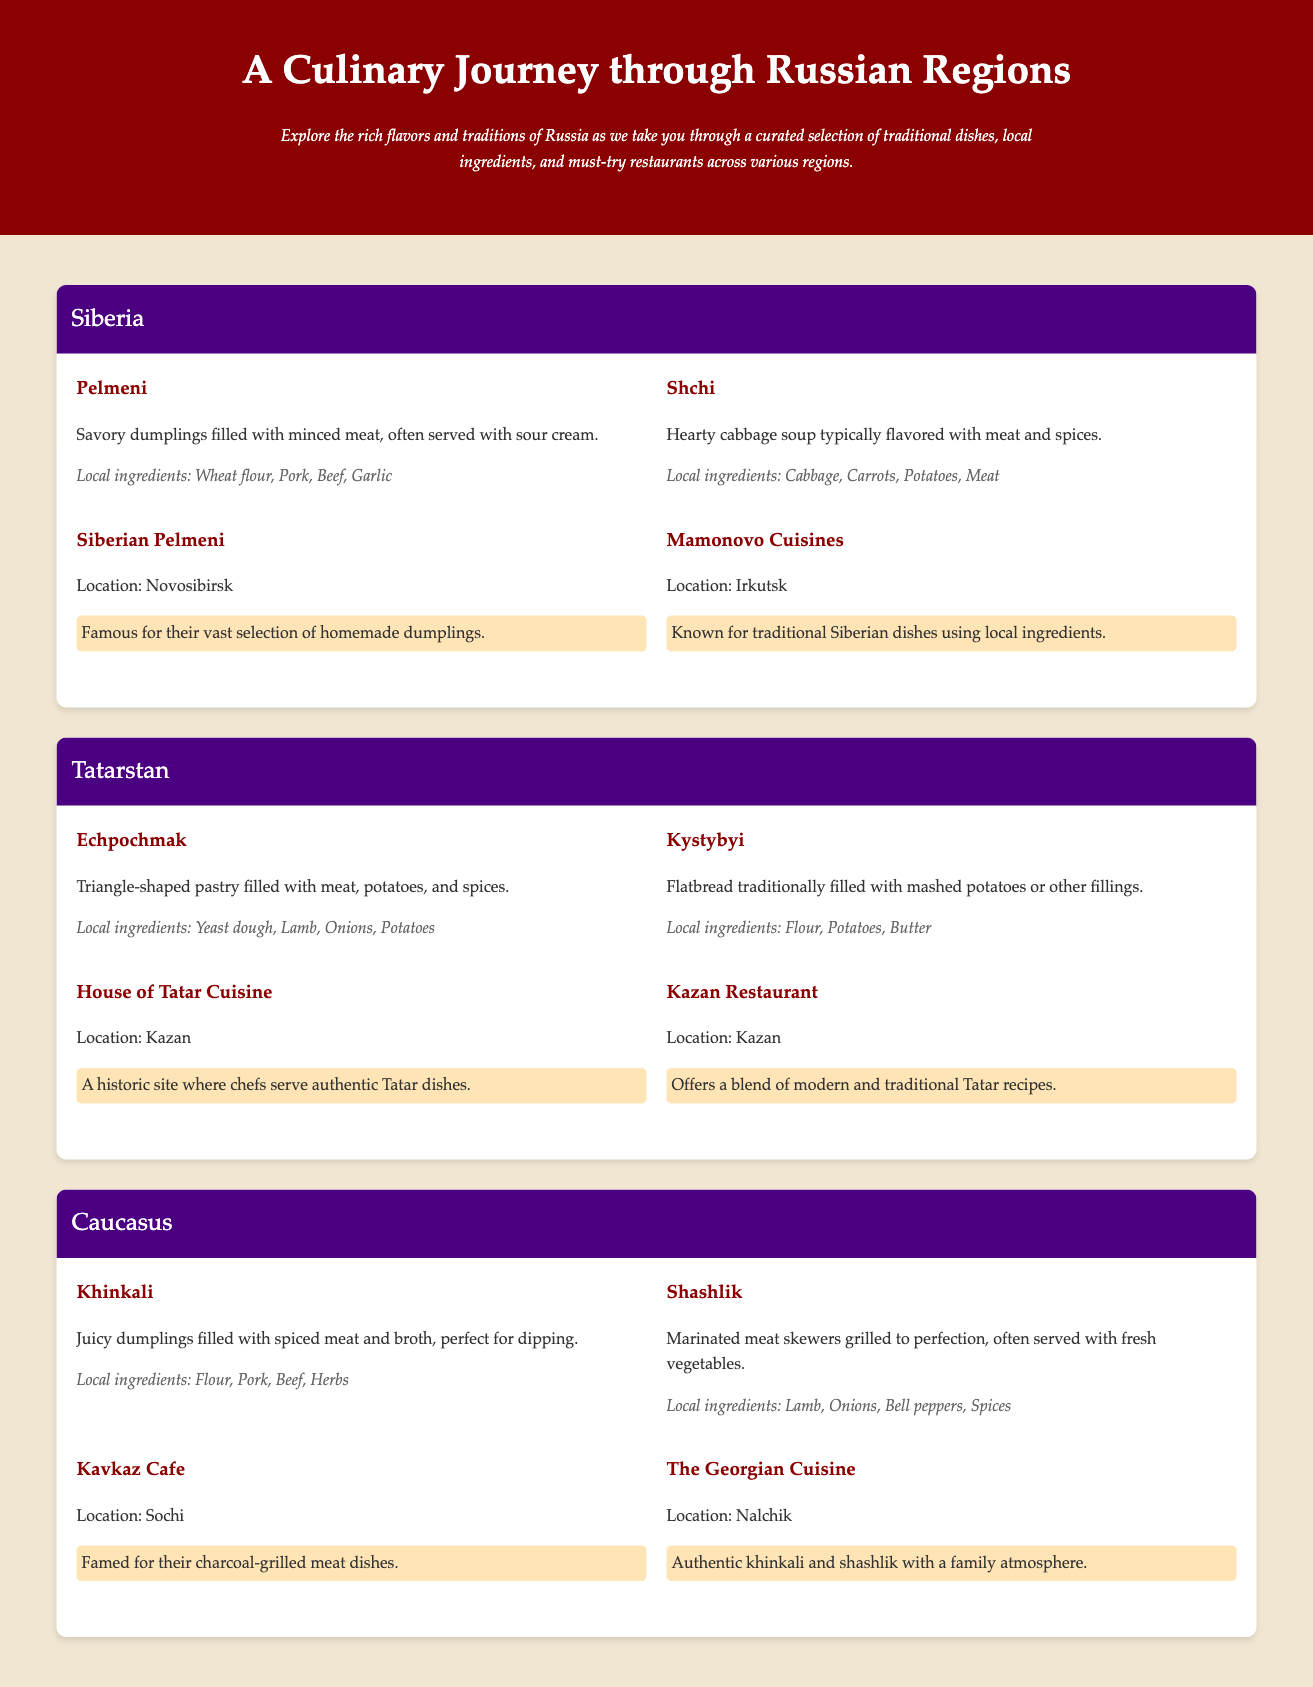What is the first dish listed under Siberia? The first dish under Siberia in the document is Pelmeni, which is mentioned first in the section for that region.
Answer: Pelmeni How many restaurants are listed for Tatarstan? The document lists two restaurants in the Tatarstan section, which are House of Tatar Cuisine and Kazan Restaurant.
Answer: 2 What local ingredient is used in both Khinkali and Shashlik? The local ingredient common to both Khinkali and Shashlik is meat, as both dishes feature spiced meat in their descriptions.
Answer: Meat Which region's restaurant is called Siberian Pelmeni? The restaurant called Siberian Pelmeni is located in the Siberia region, as indicated in the document’s restaurant listing for that area.
Answer: Siberia What type of cuisine is served at Kavkaz Cafe? Kavkaz Cafe serves charcoal-grilled meat dishes, as mentioned in the description of the restaurant in the Caucasus section.
Answer: Charcoal-grilled meat What is the unique shape of Echpochmak pastry? Echpochmak is described as a triangle-shaped pastry filled with meat, potatoes, and spices.
Answer: Triangle-shaped Which city is mentioned as the location for House of Tatar Cuisine? The location for House of Tatar Cuisine, as stated in the document, is Kazan, which is a major city in Tatarstan.
Answer: Kazan How is the atmosphere described at The Georgian Cuisine restaurant? The atmosphere at The Georgian Cuisine restaurant is described as family atmosphere in the document.
Answer: Family atmosphere 